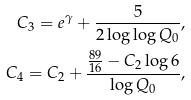<formula> <loc_0><loc_0><loc_500><loc_500>C _ { 3 } = e ^ { \gamma } + \frac { 5 } { 2 \log \log Q _ { 0 } } , \\ C _ { 4 } = C _ { 2 } + \frac { \frac { 8 9 } { 1 6 } - C _ { 2 } \log 6 } { \log Q _ { 0 } } , \\</formula> 